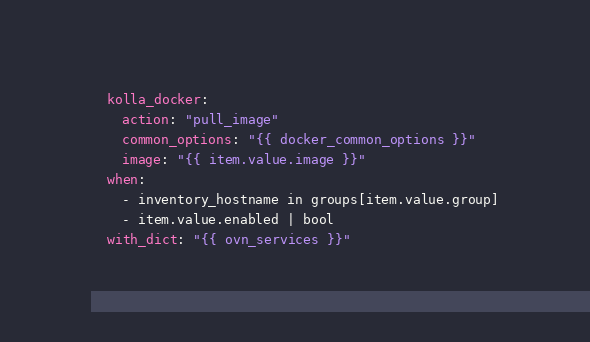Convert code to text. <code><loc_0><loc_0><loc_500><loc_500><_YAML_>  kolla_docker:
    action: "pull_image"
    common_options: "{{ docker_common_options }}"
    image: "{{ item.value.image }}"
  when:
    - inventory_hostname in groups[item.value.group]
    - item.value.enabled | bool
  with_dict: "{{ ovn_services }}"
</code> 